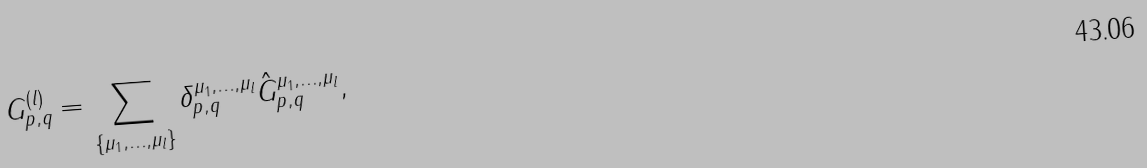Convert formula to latex. <formula><loc_0><loc_0><loc_500><loc_500>G ^ { ( l ) } _ { p , q } = \sum _ { \{ \mu _ { 1 } , \dots , \mu _ { l } \} } \delta _ { p , q } ^ { \mu _ { 1 } , \dots , \mu _ { l } } \hat { G } ^ { \mu _ { 1 } , \dots , \mu _ { l } } _ { p , q } ,</formula> 